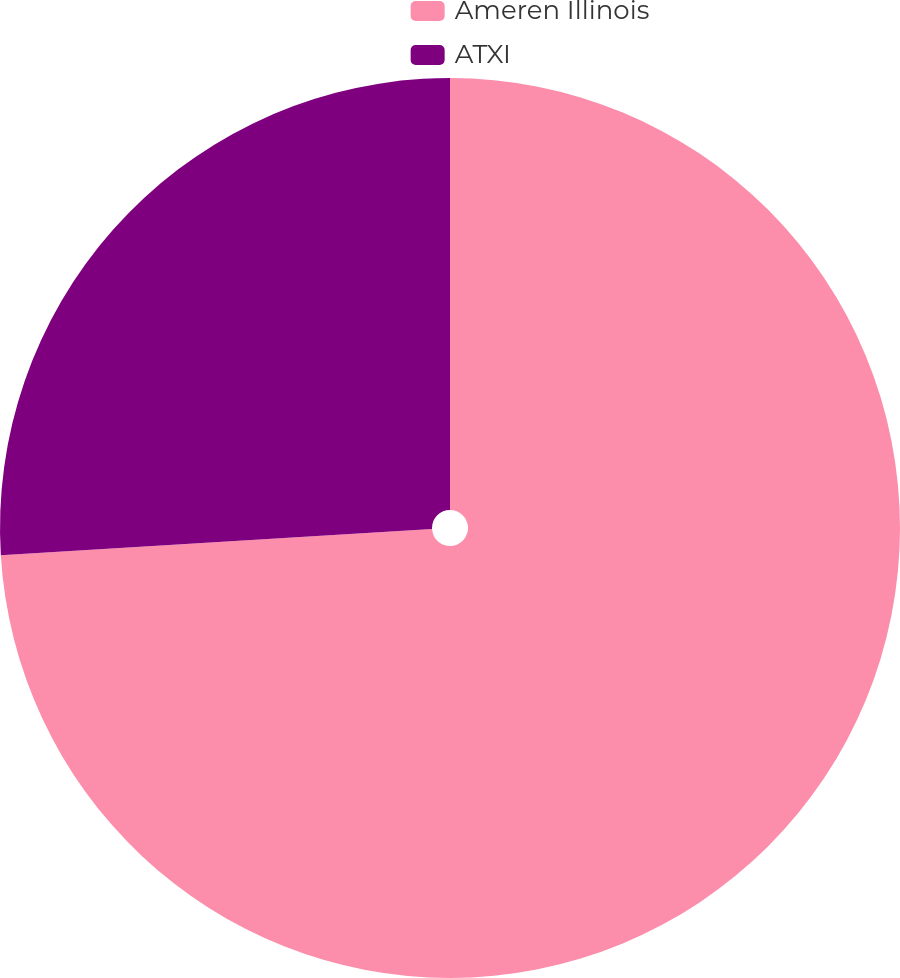Convert chart. <chart><loc_0><loc_0><loc_500><loc_500><pie_chart><fcel>Ameren Illinois<fcel>ATXI<nl><fcel>74.04%<fcel>25.96%<nl></chart> 